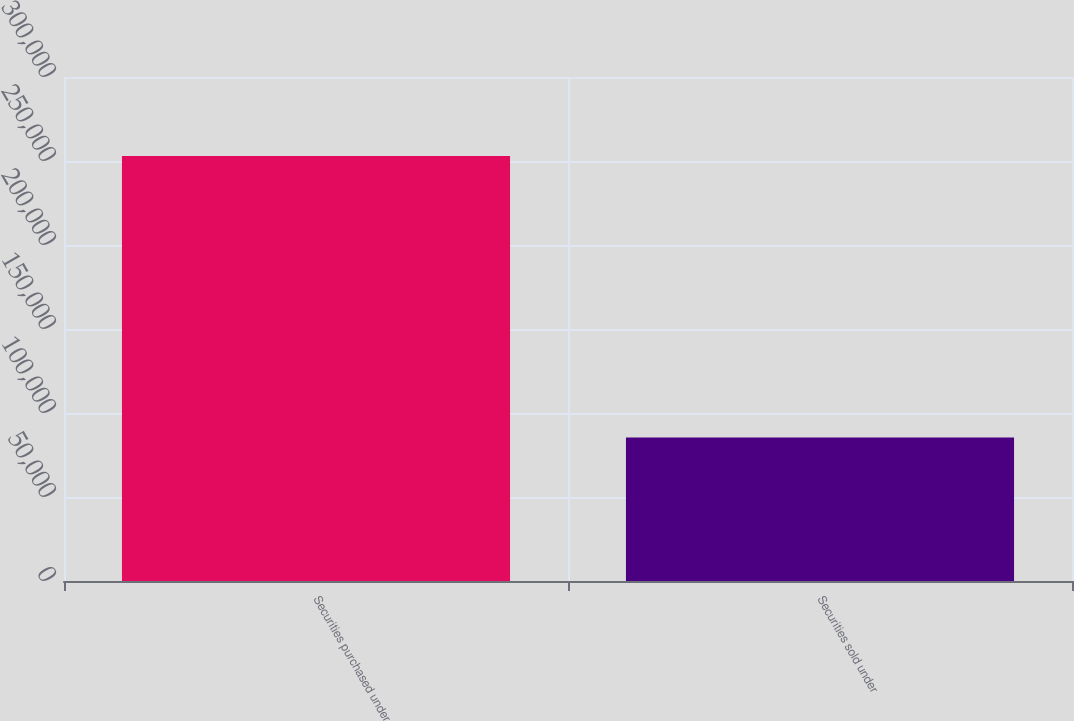<chart> <loc_0><loc_0><loc_500><loc_500><bar_chart><fcel>Securities purchased under<fcel>Securities sold under<nl><fcel>252971<fcel>85421<nl></chart> 